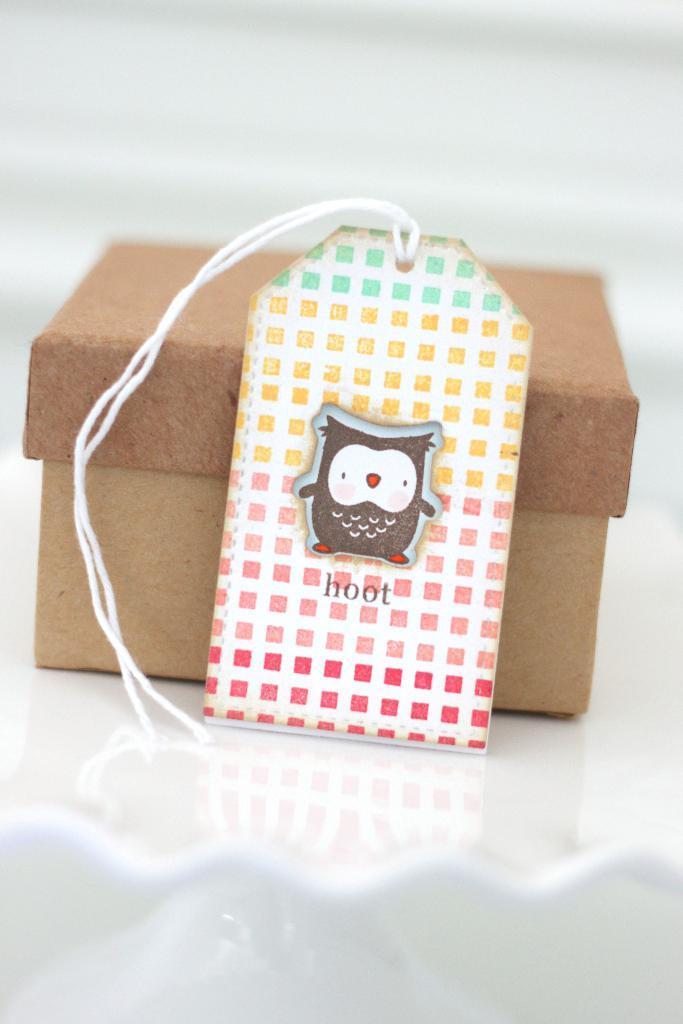How would you summarize this image in a sentence or two? In this image there is a box. In front of it there is a card with thread. 